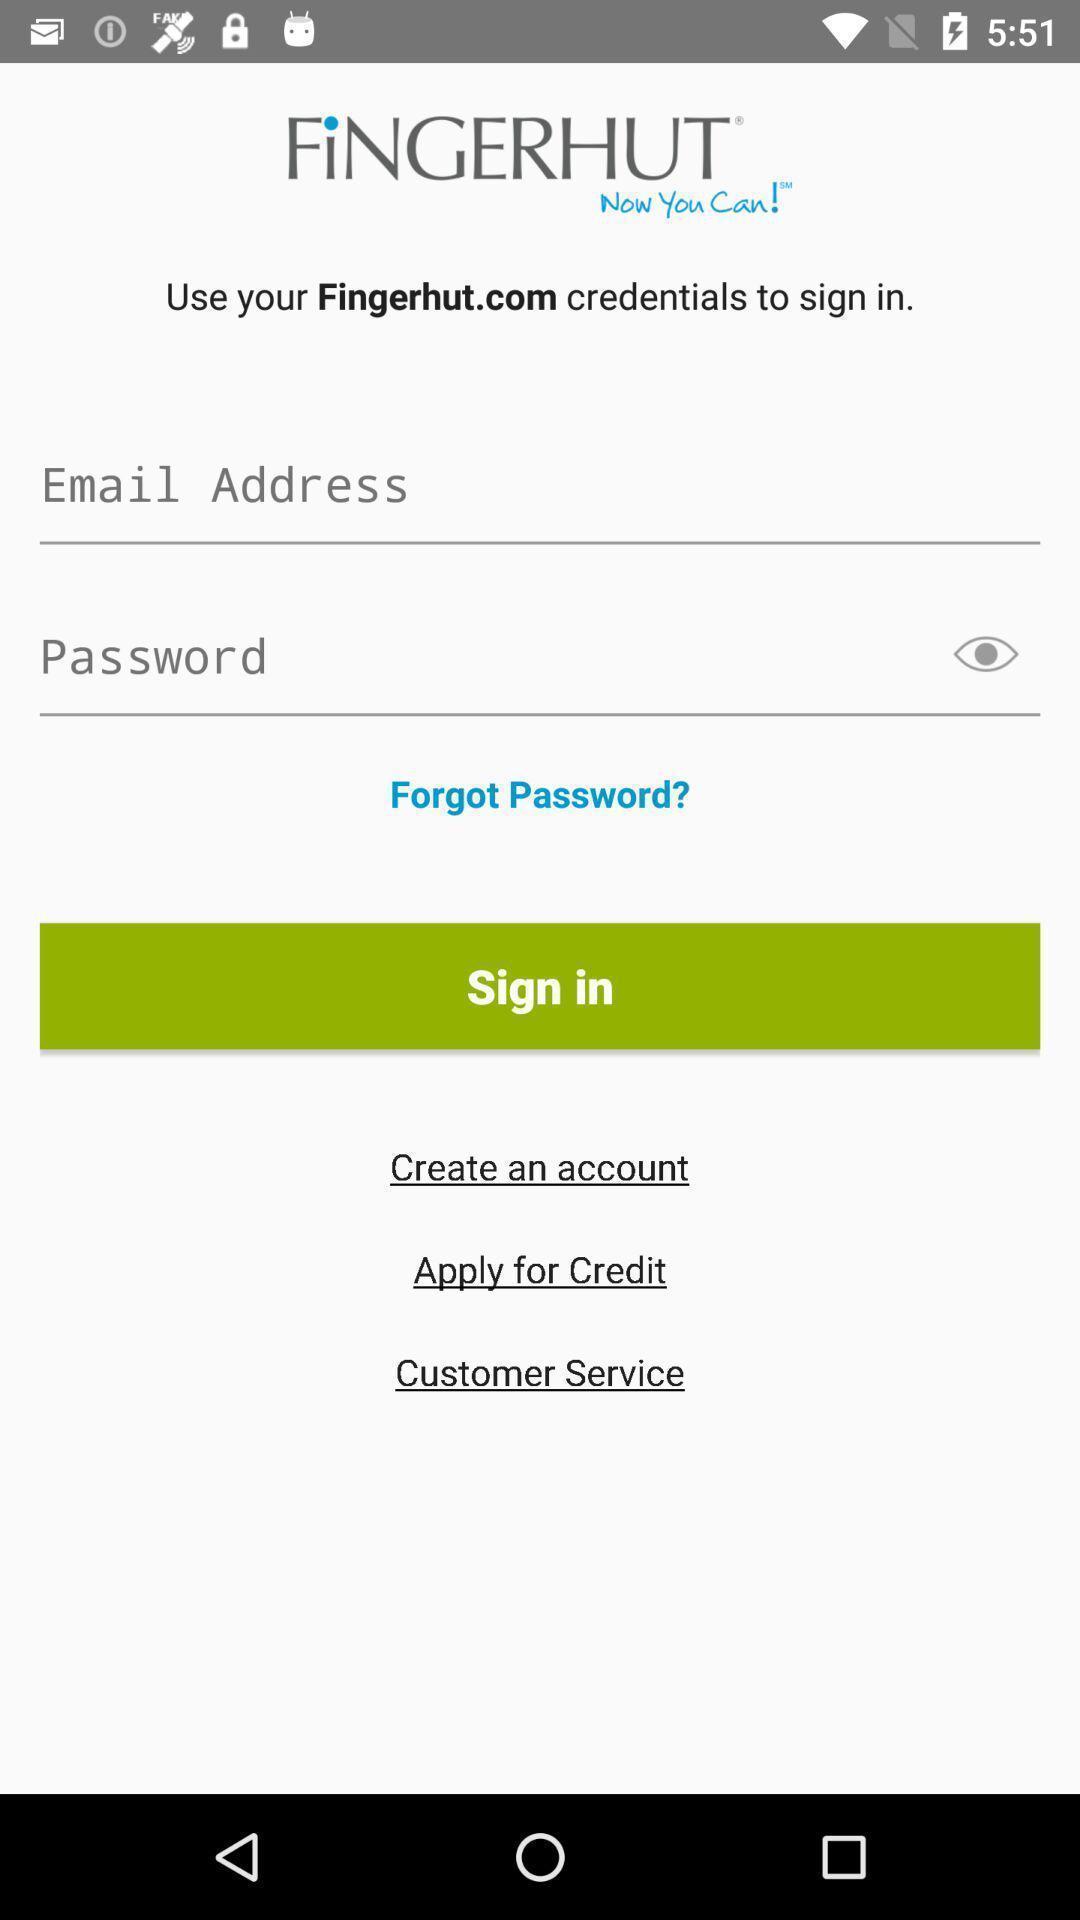Tell me about the visual elements in this screen capture. Sign in page. 